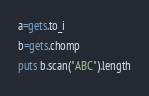Convert code to text. <code><loc_0><loc_0><loc_500><loc_500><_Ruby_>a=gets.to_i
b=gets.chomp
puts b.scan("ABC").length</code> 